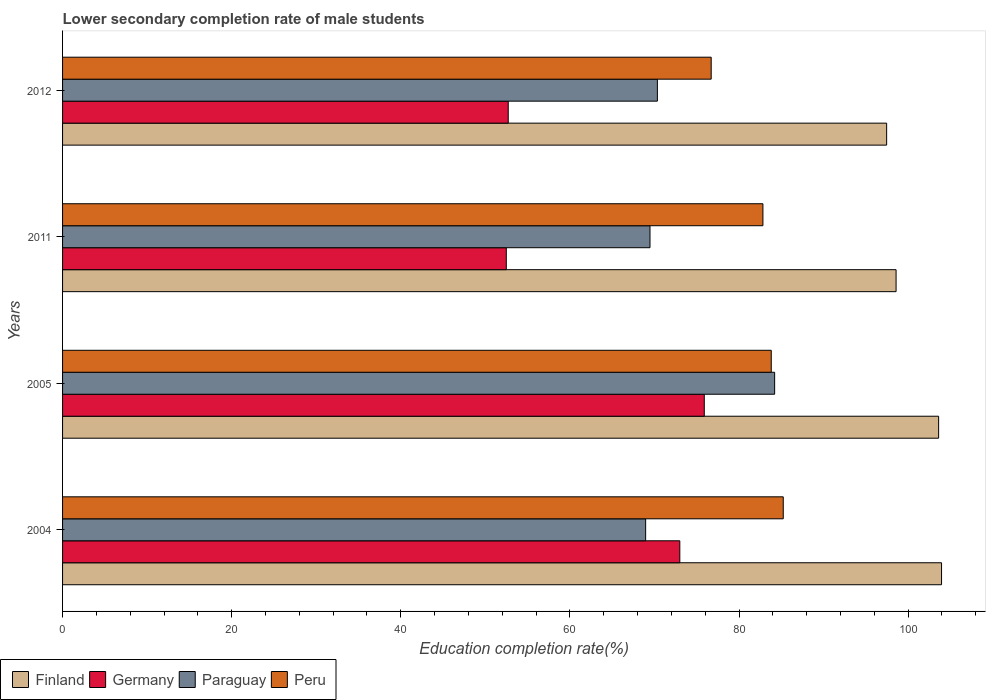How many groups of bars are there?
Your response must be concise. 4. Are the number of bars per tick equal to the number of legend labels?
Provide a succinct answer. Yes. In how many cases, is the number of bars for a given year not equal to the number of legend labels?
Provide a succinct answer. 0. What is the lower secondary completion rate of male students in Peru in 2005?
Keep it short and to the point. 83.81. Across all years, what is the maximum lower secondary completion rate of male students in Paraguay?
Keep it short and to the point. 84.21. Across all years, what is the minimum lower secondary completion rate of male students in Peru?
Offer a terse response. 76.71. What is the total lower secondary completion rate of male students in Germany in the graph?
Make the answer very short. 254.07. What is the difference between the lower secondary completion rate of male students in Finland in 2004 and that in 2011?
Your answer should be compact. 5.38. What is the difference between the lower secondary completion rate of male students in Germany in 2005 and the lower secondary completion rate of male students in Peru in 2011?
Give a very brief answer. -6.94. What is the average lower secondary completion rate of male students in Paraguay per year?
Offer a terse response. 73.25. In the year 2012, what is the difference between the lower secondary completion rate of male students in Finland and lower secondary completion rate of male students in Paraguay?
Ensure brevity in your answer.  27.11. What is the ratio of the lower secondary completion rate of male students in Peru in 2004 to that in 2005?
Keep it short and to the point. 1.02. What is the difference between the highest and the second highest lower secondary completion rate of male students in Peru?
Your answer should be compact. 1.42. What is the difference between the highest and the lowest lower secondary completion rate of male students in Peru?
Keep it short and to the point. 8.52. Is the sum of the lower secondary completion rate of male students in Finland in 2011 and 2012 greater than the maximum lower secondary completion rate of male students in Paraguay across all years?
Your answer should be compact. Yes. What does the 2nd bar from the top in 2012 represents?
Keep it short and to the point. Paraguay. Is it the case that in every year, the sum of the lower secondary completion rate of male students in Finland and lower secondary completion rate of male students in Germany is greater than the lower secondary completion rate of male students in Peru?
Offer a terse response. Yes. Are all the bars in the graph horizontal?
Offer a terse response. Yes. What is the difference between two consecutive major ticks on the X-axis?
Your answer should be very brief. 20. Are the values on the major ticks of X-axis written in scientific E-notation?
Provide a succinct answer. No. Does the graph contain grids?
Keep it short and to the point. No. Where does the legend appear in the graph?
Offer a terse response. Bottom left. How are the legend labels stacked?
Provide a succinct answer. Horizontal. What is the title of the graph?
Your response must be concise. Lower secondary completion rate of male students. Does "Least developed countries" appear as one of the legend labels in the graph?
Keep it short and to the point. No. What is the label or title of the X-axis?
Give a very brief answer. Education completion rate(%). What is the Education completion rate(%) of Finland in 2004?
Offer a very short reply. 103.95. What is the Education completion rate(%) of Germany in 2004?
Give a very brief answer. 73. What is the Education completion rate(%) in Paraguay in 2004?
Provide a short and direct response. 68.96. What is the Education completion rate(%) in Peru in 2004?
Your response must be concise. 85.23. What is the Education completion rate(%) of Finland in 2005?
Ensure brevity in your answer.  103.61. What is the Education completion rate(%) of Germany in 2005?
Provide a short and direct response. 75.89. What is the Education completion rate(%) in Paraguay in 2005?
Keep it short and to the point. 84.21. What is the Education completion rate(%) in Peru in 2005?
Make the answer very short. 83.81. What is the Education completion rate(%) in Finland in 2011?
Offer a terse response. 98.57. What is the Education completion rate(%) of Germany in 2011?
Keep it short and to the point. 52.48. What is the Education completion rate(%) in Paraguay in 2011?
Provide a short and direct response. 69.47. What is the Education completion rate(%) of Peru in 2011?
Offer a terse response. 82.83. What is the Education completion rate(%) in Finland in 2012?
Your answer should be compact. 97.46. What is the Education completion rate(%) in Germany in 2012?
Offer a terse response. 52.71. What is the Education completion rate(%) in Paraguay in 2012?
Provide a short and direct response. 70.35. What is the Education completion rate(%) in Peru in 2012?
Provide a short and direct response. 76.71. Across all years, what is the maximum Education completion rate(%) in Finland?
Your response must be concise. 103.95. Across all years, what is the maximum Education completion rate(%) of Germany?
Provide a succinct answer. 75.89. Across all years, what is the maximum Education completion rate(%) of Paraguay?
Your answer should be compact. 84.21. Across all years, what is the maximum Education completion rate(%) in Peru?
Provide a short and direct response. 85.23. Across all years, what is the minimum Education completion rate(%) of Finland?
Your response must be concise. 97.46. Across all years, what is the minimum Education completion rate(%) of Germany?
Provide a succinct answer. 52.48. Across all years, what is the minimum Education completion rate(%) in Paraguay?
Your response must be concise. 68.96. Across all years, what is the minimum Education completion rate(%) in Peru?
Make the answer very short. 76.71. What is the total Education completion rate(%) in Finland in the graph?
Keep it short and to the point. 403.59. What is the total Education completion rate(%) in Germany in the graph?
Your answer should be very brief. 254.07. What is the total Education completion rate(%) in Paraguay in the graph?
Give a very brief answer. 292.99. What is the total Education completion rate(%) of Peru in the graph?
Give a very brief answer. 328.58. What is the difference between the Education completion rate(%) of Finland in 2004 and that in 2005?
Provide a succinct answer. 0.35. What is the difference between the Education completion rate(%) in Germany in 2004 and that in 2005?
Your response must be concise. -2.89. What is the difference between the Education completion rate(%) of Paraguay in 2004 and that in 2005?
Your answer should be compact. -15.26. What is the difference between the Education completion rate(%) in Peru in 2004 and that in 2005?
Provide a succinct answer. 1.42. What is the difference between the Education completion rate(%) of Finland in 2004 and that in 2011?
Ensure brevity in your answer.  5.38. What is the difference between the Education completion rate(%) of Germany in 2004 and that in 2011?
Give a very brief answer. 20.52. What is the difference between the Education completion rate(%) in Paraguay in 2004 and that in 2011?
Make the answer very short. -0.51. What is the difference between the Education completion rate(%) in Peru in 2004 and that in 2011?
Make the answer very short. 2.4. What is the difference between the Education completion rate(%) in Finland in 2004 and that in 2012?
Your answer should be very brief. 6.49. What is the difference between the Education completion rate(%) of Germany in 2004 and that in 2012?
Your response must be concise. 20.29. What is the difference between the Education completion rate(%) in Paraguay in 2004 and that in 2012?
Provide a short and direct response. -1.39. What is the difference between the Education completion rate(%) in Peru in 2004 and that in 2012?
Your response must be concise. 8.52. What is the difference between the Education completion rate(%) in Finland in 2005 and that in 2011?
Your answer should be compact. 5.03. What is the difference between the Education completion rate(%) of Germany in 2005 and that in 2011?
Your answer should be compact. 23.41. What is the difference between the Education completion rate(%) of Paraguay in 2005 and that in 2011?
Your answer should be compact. 14.74. What is the difference between the Education completion rate(%) in Peru in 2005 and that in 2011?
Offer a very short reply. 0.98. What is the difference between the Education completion rate(%) in Finland in 2005 and that in 2012?
Provide a short and direct response. 6.15. What is the difference between the Education completion rate(%) of Germany in 2005 and that in 2012?
Give a very brief answer. 23.19. What is the difference between the Education completion rate(%) of Paraguay in 2005 and that in 2012?
Provide a short and direct response. 13.87. What is the difference between the Education completion rate(%) in Peru in 2005 and that in 2012?
Your answer should be very brief. 7.1. What is the difference between the Education completion rate(%) in Finland in 2011 and that in 2012?
Your response must be concise. 1.12. What is the difference between the Education completion rate(%) of Germany in 2011 and that in 2012?
Your answer should be compact. -0.23. What is the difference between the Education completion rate(%) in Paraguay in 2011 and that in 2012?
Keep it short and to the point. -0.88. What is the difference between the Education completion rate(%) in Peru in 2011 and that in 2012?
Keep it short and to the point. 6.12. What is the difference between the Education completion rate(%) in Finland in 2004 and the Education completion rate(%) in Germany in 2005?
Offer a terse response. 28.06. What is the difference between the Education completion rate(%) of Finland in 2004 and the Education completion rate(%) of Paraguay in 2005?
Your answer should be very brief. 19.74. What is the difference between the Education completion rate(%) of Finland in 2004 and the Education completion rate(%) of Peru in 2005?
Your response must be concise. 20.14. What is the difference between the Education completion rate(%) in Germany in 2004 and the Education completion rate(%) in Paraguay in 2005?
Ensure brevity in your answer.  -11.21. What is the difference between the Education completion rate(%) of Germany in 2004 and the Education completion rate(%) of Peru in 2005?
Provide a short and direct response. -10.81. What is the difference between the Education completion rate(%) of Paraguay in 2004 and the Education completion rate(%) of Peru in 2005?
Give a very brief answer. -14.86. What is the difference between the Education completion rate(%) in Finland in 2004 and the Education completion rate(%) in Germany in 2011?
Provide a short and direct response. 51.47. What is the difference between the Education completion rate(%) of Finland in 2004 and the Education completion rate(%) of Paraguay in 2011?
Provide a short and direct response. 34.48. What is the difference between the Education completion rate(%) in Finland in 2004 and the Education completion rate(%) in Peru in 2011?
Keep it short and to the point. 21.12. What is the difference between the Education completion rate(%) in Germany in 2004 and the Education completion rate(%) in Paraguay in 2011?
Give a very brief answer. 3.53. What is the difference between the Education completion rate(%) of Germany in 2004 and the Education completion rate(%) of Peru in 2011?
Provide a short and direct response. -9.83. What is the difference between the Education completion rate(%) of Paraguay in 2004 and the Education completion rate(%) of Peru in 2011?
Give a very brief answer. -13.87. What is the difference between the Education completion rate(%) in Finland in 2004 and the Education completion rate(%) in Germany in 2012?
Provide a short and direct response. 51.25. What is the difference between the Education completion rate(%) in Finland in 2004 and the Education completion rate(%) in Paraguay in 2012?
Offer a very short reply. 33.6. What is the difference between the Education completion rate(%) in Finland in 2004 and the Education completion rate(%) in Peru in 2012?
Give a very brief answer. 27.24. What is the difference between the Education completion rate(%) in Germany in 2004 and the Education completion rate(%) in Paraguay in 2012?
Offer a very short reply. 2.65. What is the difference between the Education completion rate(%) of Germany in 2004 and the Education completion rate(%) of Peru in 2012?
Offer a very short reply. -3.71. What is the difference between the Education completion rate(%) in Paraguay in 2004 and the Education completion rate(%) in Peru in 2012?
Your response must be concise. -7.75. What is the difference between the Education completion rate(%) in Finland in 2005 and the Education completion rate(%) in Germany in 2011?
Give a very brief answer. 51.13. What is the difference between the Education completion rate(%) in Finland in 2005 and the Education completion rate(%) in Paraguay in 2011?
Give a very brief answer. 34.13. What is the difference between the Education completion rate(%) of Finland in 2005 and the Education completion rate(%) of Peru in 2011?
Ensure brevity in your answer.  20.78. What is the difference between the Education completion rate(%) of Germany in 2005 and the Education completion rate(%) of Paraguay in 2011?
Ensure brevity in your answer.  6.42. What is the difference between the Education completion rate(%) in Germany in 2005 and the Education completion rate(%) in Peru in 2011?
Provide a succinct answer. -6.94. What is the difference between the Education completion rate(%) of Paraguay in 2005 and the Education completion rate(%) of Peru in 2011?
Ensure brevity in your answer.  1.39. What is the difference between the Education completion rate(%) of Finland in 2005 and the Education completion rate(%) of Germany in 2012?
Your answer should be very brief. 50.9. What is the difference between the Education completion rate(%) of Finland in 2005 and the Education completion rate(%) of Paraguay in 2012?
Provide a short and direct response. 33.26. What is the difference between the Education completion rate(%) in Finland in 2005 and the Education completion rate(%) in Peru in 2012?
Make the answer very short. 26.9. What is the difference between the Education completion rate(%) of Germany in 2005 and the Education completion rate(%) of Paraguay in 2012?
Your answer should be compact. 5.54. What is the difference between the Education completion rate(%) in Germany in 2005 and the Education completion rate(%) in Peru in 2012?
Your response must be concise. -0.82. What is the difference between the Education completion rate(%) in Paraguay in 2005 and the Education completion rate(%) in Peru in 2012?
Offer a very short reply. 7.5. What is the difference between the Education completion rate(%) of Finland in 2011 and the Education completion rate(%) of Germany in 2012?
Offer a very short reply. 45.87. What is the difference between the Education completion rate(%) of Finland in 2011 and the Education completion rate(%) of Paraguay in 2012?
Your response must be concise. 28.23. What is the difference between the Education completion rate(%) of Finland in 2011 and the Education completion rate(%) of Peru in 2012?
Provide a succinct answer. 21.87. What is the difference between the Education completion rate(%) of Germany in 2011 and the Education completion rate(%) of Paraguay in 2012?
Make the answer very short. -17.87. What is the difference between the Education completion rate(%) of Germany in 2011 and the Education completion rate(%) of Peru in 2012?
Provide a succinct answer. -24.23. What is the difference between the Education completion rate(%) of Paraguay in 2011 and the Education completion rate(%) of Peru in 2012?
Make the answer very short. -7.24. What is the average Education completion rate(%) of Finland per year?
Give a very brief answer. 100.9. What is the average Education completion rate(%) of Germany per year?
Offer a terse response. 63.52. What is the average Education completion rate(%) of Paraguay per year?
Your response must be concise. 73.25. What is the average Education completion rate(%) in Peru per year?
Give a very brief answer. 82.14. In the year 2004, what is the difference between the Education completion rate(%) in Finland and Education completion rate(%) in Germany?
Provide a succinct answer. 30.95. In the year 2004, what is the difference between the Education completion rate(%) in Finland and Education completion rate(%) in Paraguay?
Your answer should be very brief. 34.99. In the year 2004, what is the difference between the Education completion rate(%) in Finland and Education completion rate(%) in Peru?
Your answer should be compact. 18.72. In the year 2004, what is the difference between the Education completion rate(%) in Germany and Education completion rate(%) in Paraguay?
Your answer should be compact. 4.04. In the year 2004, what is the difference between the Education completion rate(%) of Germany and Education completion rate(%) of Peru?
Your response must be concise. -12.23. In the year 2004, what is the difference between the Education completion rate(%) in Paraguay and Education completion rate(%) in Peru?
Make the answer very short. -16.27. In the year 2005, what is the difference between the Education completion rate(%) in Finland and Education completion rate(%) in Germany?
Offer a very short reply. 27.71. In the year 2005, what is the difference between the Education completion rate(%) in Finland and Education completion rate(%) in Paraguay?
Your response must be concise. 19.39. In the year 2005, what is the difference between the Education completion rate(%) of Finland and Education completion rate(%) of Peru?
Provide a succinct answer. 19.79. In the year 2005, what is the difference between the Education completion rate(%) in Germany and Education completion rate(%) in Paraguay?
Provide a succinct answer. -8.32. In the year 2005, what is the difference between the Education completion rate(%) in Germany and Education completion rate(%) in Peru?
Offer a terse response. -7.92. In the year 2005, what is the difference between the Education completion rate(%) in Paraguay and Education completion rate(%) in Peru?
Make the answer very short. 0.4. In the year 2011, what is the difference between the Education completion rate(%) of Finland and Education completion rate(%) of Germany?
Your response must be concise. 46.1. In the year 2011, what is the difference between the Education completion rate(%) in Finland and Education completion rate(%) in Paraguay?
Ensure brevity in your answer.  29.1. In the year 2011, what is the difference between the Education completion rate(%) in Finland and Education completion rate(%) in Peru?
Your response must be concise. 15.75. In the year 2011, what is the difference between the Education completion rate(%) of Germany and Education completion rate(%) of Paraguay?
Provide a succinct answer. -16.99. In the year 2011, what is the difference between the Education completion rate(%) of Germany and Education completion rate(%) of Peru?
Make the answer very short. -30.35. In the year 2011, what is the difference between the Education completion rate(%) in Paraguay and Education completion rate(%) in Peru?
Make the answer very short. -13.36. In the year 2012, what is the difference between the Education completion rate(%) in Finland and Education completion rate(%) in Germany?
Keep it short and to the point. 44.75. In the year 2012, what is the difference between the Education completion rate(%) of Finland and Education completion rate(%) of Paraguay?
Keep it short and to the point. 27.11. In the year 2012, what is the difference between the Education completion rate(%) of Finland and Education completion rate(%) of Peru?
Provide a succinct answer. 20.75. In the year 2012, what is the difference between the Education completion rate(%) of Germany and Education completion rate(%) of Paraguay?
Offer a very short reply. -17.64. In the year 2012, what is the difference between the Education completion rate(%) of Germany and Education completion rate(%) of Peru?
Your answer should be compact. -24. In the year 2012, what is the difference between the Education completion rate(%) in Paraguay and Education completion rate(%) in Peru?
Offer a very short reply. -6.36. What is the ratio of the Education completion rate(%) in Finland in 2004 to that in 2005?
Make the answer very short. 1. What is the ratio of the Education completion rate(%) of Germany in 2004 to that in 2005?
Offer a very short reply. 0.96. What is the ratio of the Education completion rate(%) of Paraguay in 2004 to that in 2005?
Offer a terse response. 0.82. What is the ratio of the Education completion rate(%) of Peru in 2004 to that in 2005?
Your answer should be very brief. 1.02. What is the ratio of the Education completion rate(%) of Finland in 2004 to that in 2011?
Offer a terse response. 1.05. What is the ratio of the Education completion rate(%) of Germany in 2004 to that in 2011?
Ensure brevity in your answer.  1.39. What is the ratio of the Education completion rate(%) of Paraguay in 2004 to that in 2011?
Offer a terse response. 0.99. What is the ratio of the Education completion rate(%) of Finland in 2004 to that in 2012?
Provide a short and direct response. 1.07. What is the ratio of the Education completion rate(%) of Germany in 2004 to that in 2012?
Offer a very short reply. 1.39. What is the ratio of the Education completion rate(%) in Paraguay in 2004 to that in 2012?
Your answer should be compact. 0.98. What is the ratio of the Education completion rate(%) in Finland in 2005 to that in 2011?
Ensure brevity in your answer.  1.05. What is the ratio of the Education completion rate(%) in Germany in 2005 to that in 2011?
Offer a very short reply. 1.45. What is the ratio of the Education completion rate(%) in Paraguay in 2005 to that in 2011?
Provide a short and direct response. 1.21. What is the ratio of the Education completion rate(%) in Peru in 2005 to that in 2011?
Give a very brief answer. 1.01. What is the ratio of the Education completion rate(%) in Finland in 2005 to that in 2012?
Keep it short and to the point. 1.06. What is the ratio of the Education completion rate(%) in Germany in 2005 to that in 2012?
Your response must be concise. 1.44. What is the ratio of the Education completion rate(%) in Paraguay in 2005 to that in 2012?
Your answer should be compact. 1.2. What is the ratio of the Education completion rate(%) of Peru in 2005 to that in 2012?
Offer a terse response. 1.09. What is the ratio of the Education completion rate(%) in Finland in 2011 to that in 2012?
Give a very brief answer. 1.01. What is the ratio of the Education completion rate(%) in Paraguay in 2011 to that in 2012?
Make the answer very short. 0.99. What is the ratio of the Education completion rate(%) in Peru in 2011 to that in 2012?
Your answer should be very brief. 1.08. What is the difference between the highest and the second highest Education completion rate(%) in Finland?
Provide a succinct answer. 0.35. What is the difference between the highest and the second highest Education completion rate(%) in Germany?
Provide a short and direct response. 2.89. What is the difference between the highest and the second highest Education completion rate(%) in Paraguay?
Provide a succinct answer. 13.87. What is the difference between the highest and the second highest Education completion rate(%) of Peru?
Provide a short and direct response. 1.42. What is the difference between the highest and the lowest Education completion rate(%) of Finland?
Ensure brevity in your answer.  6.49. What is the difference between the highest and the lowest Education completion rate(%) of Germany?
Provide a succinct answer. 23.41. What is the difference between the highest and the lowest Education completion rate(%) in Paraguay?
Give a very brief answer. 15.26. What is the difference between the highest and the lowest Education completion rate(%) of Peru?
Offer a very short reply. 8.52. 